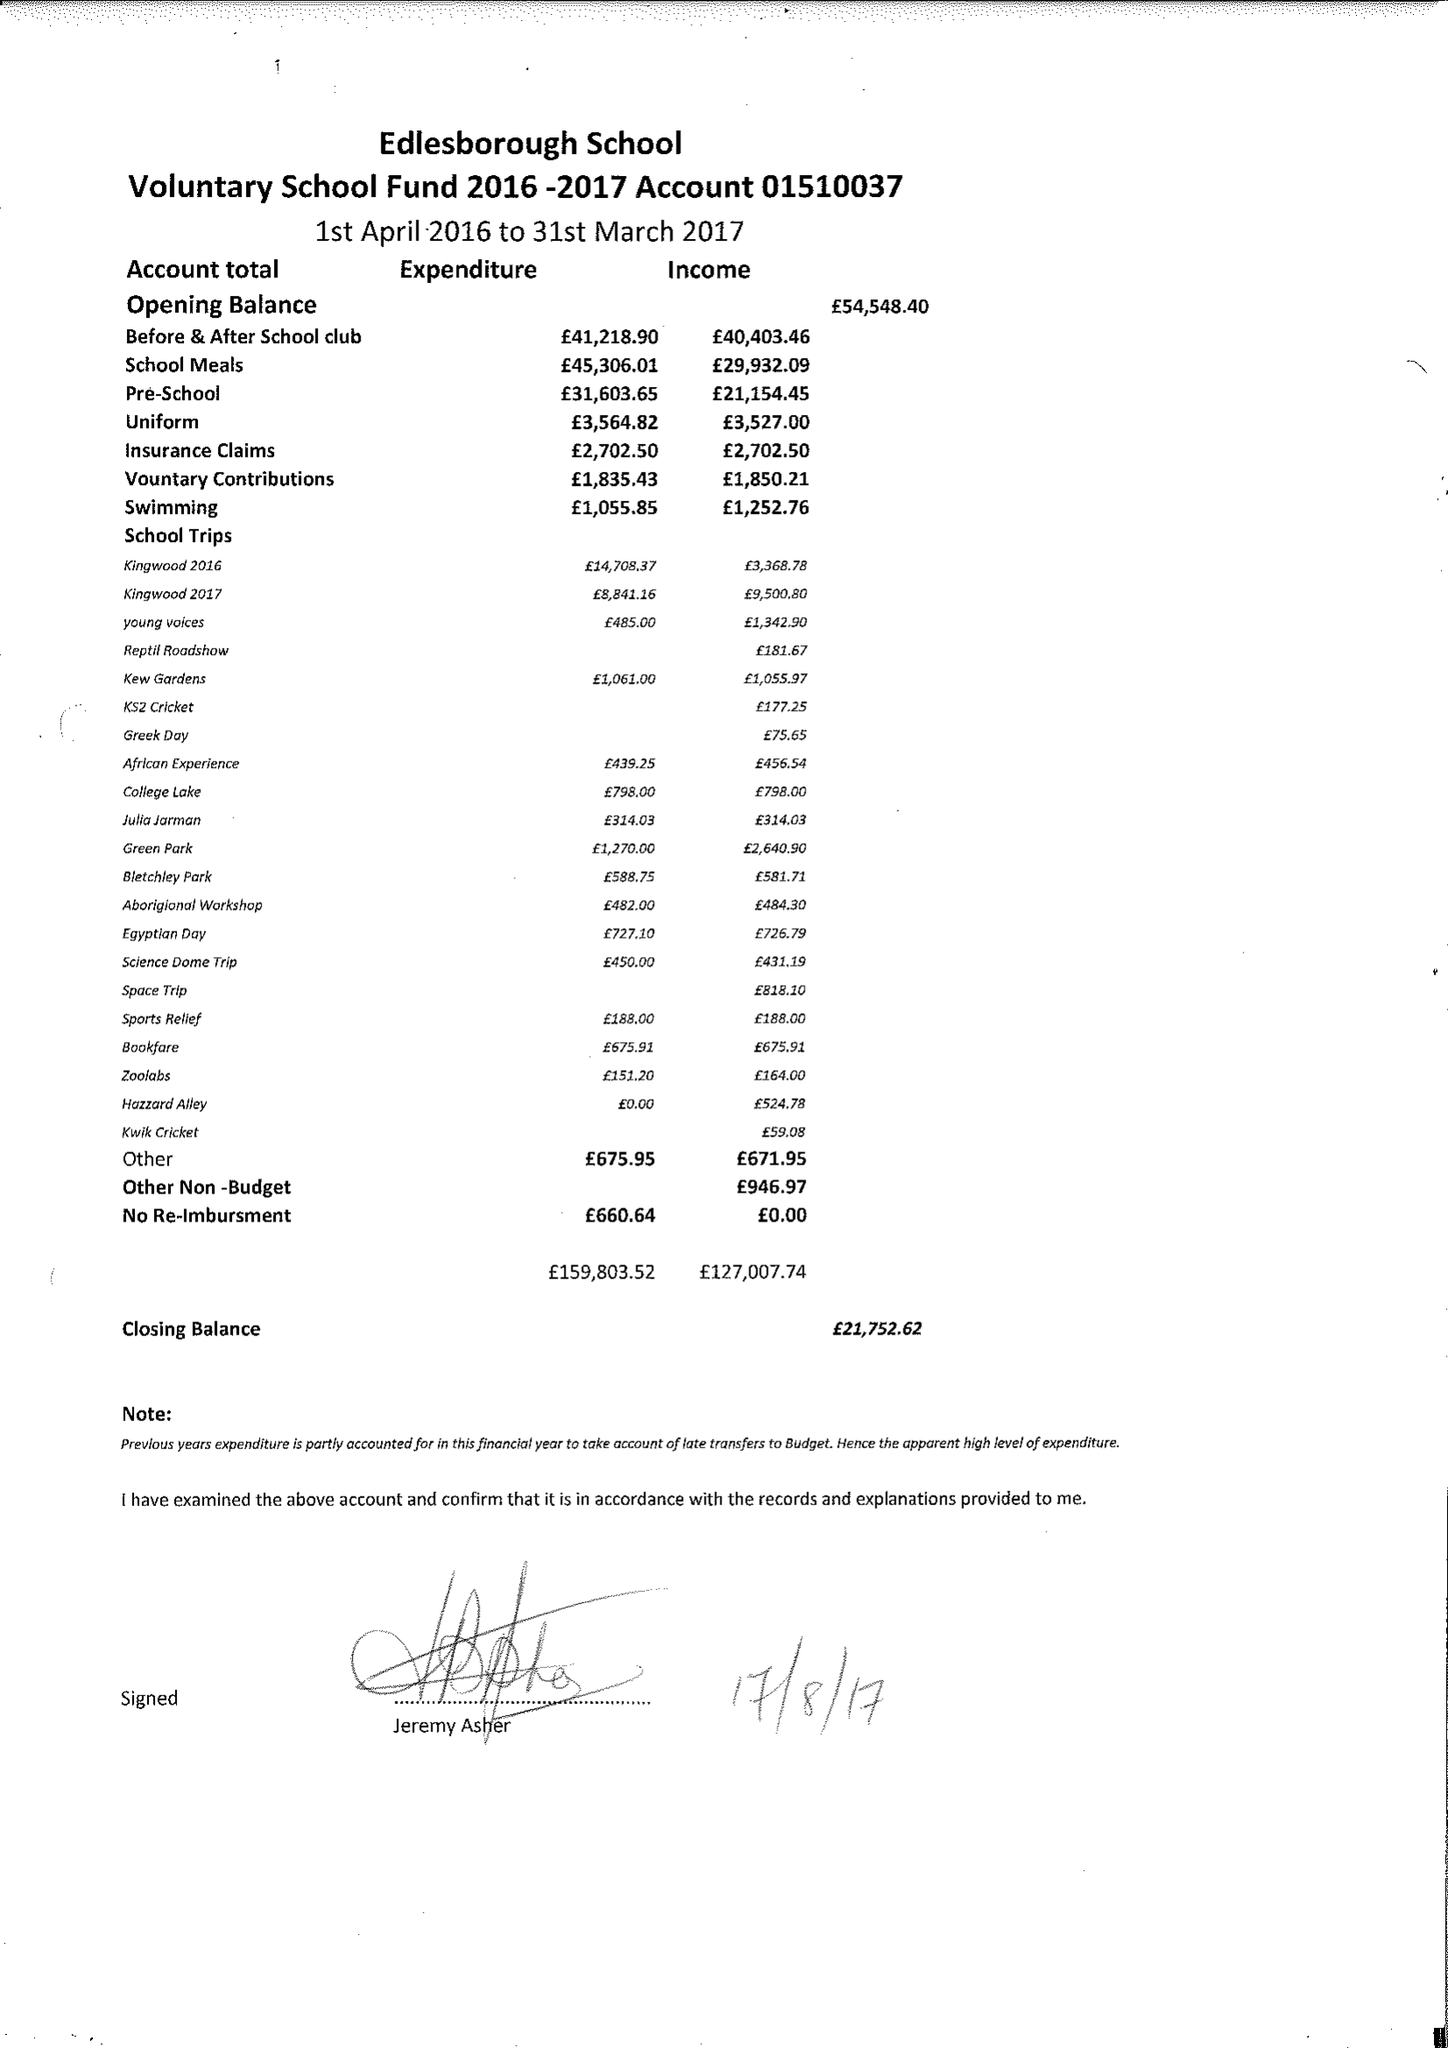What is the value for the income_annually_in_british_pounds?
Answer the question using a single word or phrase. 127007.74 